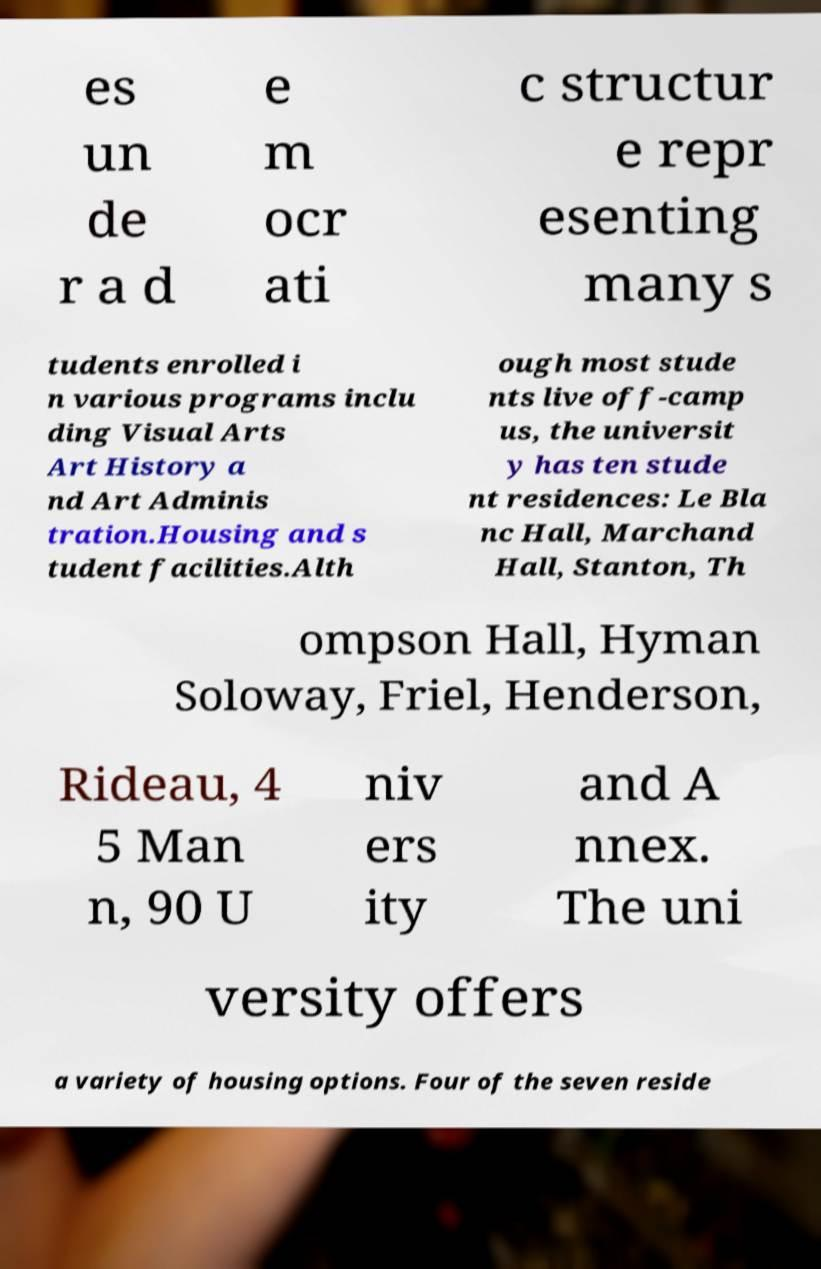What messages or text are displayed in this image? I need them in a readable, typed format. es un de r a d e m ocr ati c structur e repr esenting many s tudents enrolled i n various programs inclu ding Visual Arts Art History a nd Art Adminis tration.Housing and s tudent facilities.Alth ough most stude nts live off-camp us, the universit y has ten stude nt residences: Le Bla nc Hall, Marchand Hall, Stanton, Th ompson Hall, Hyman Soloway, Friel, Henderson, Rideau, 4 5 Man n, 90 U niv ers ity and A nnex. The uni versity offers a variety of housing options. Four of the seven reside 